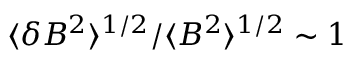<formula> <loc_0><loc_0><loc_500><loc_500>\langle \delta B ^ { 2 } \rangle ^ { 1 / 2 } / \langle B ^ { 2 } \rangle ^ { 1 / 2 } \sim 1</formula> 